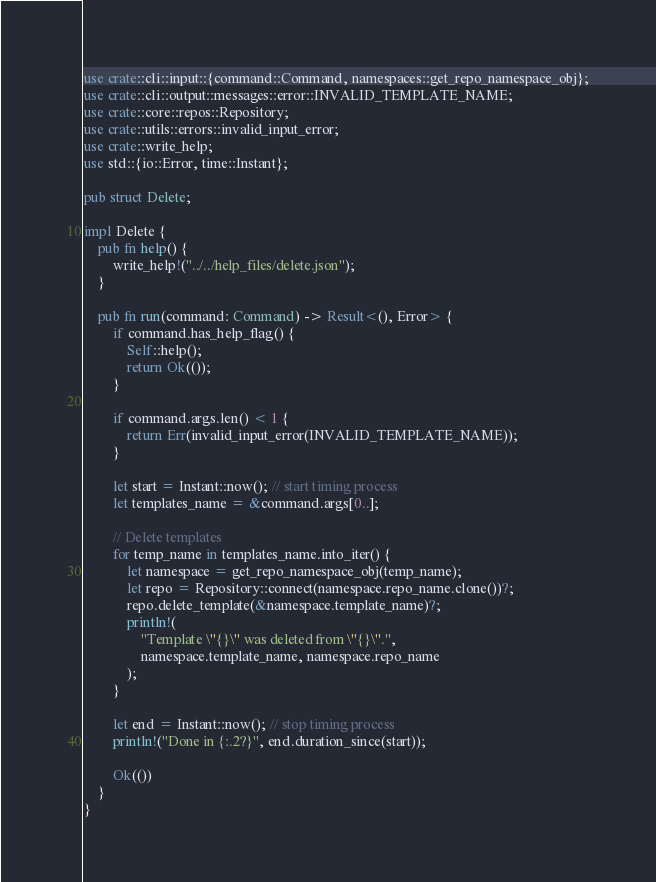Convert code to text. <code><loc_0><loc_0><loc_500><loc_500><_Rust_>use crate::cli::input::{command::Command, namespaces::get_repo_namespace_obj};
use crate::cli::output::messages::error::INVALID_TEMPLATE_NAME;
use crate::core::repos::Repository;
use crate::utils::errors::invalid_input_error;
use crate::write_help;
use std::{io::Error, time::Instant};

pub struct Delete;

impl Delete {
    pub fn help() {
        write_help!("../../help_files/delete.json");
    }

    pub fn run(command: Command) -> Result<(), Error> {
        if command.has_help_flag() {
            Self::help();
            return Ok(());
        }

        if command.args.len() < 1 {
            return Err(invalid_input_error(INVALID_TEMPLATE_NAME));
        }

        let start = Instant::now(); // start timing process
        let templates_name = &command.args[0..];

        // Delete templates
        for temp_name in templates_name.into_iter() {
            let namespace = get_repo_namespace_obj(temp_name);
            let repo = Repository::connect(namespace.repo_name.clone())?;
            repo.delete_template(&namespace.template_name)?;
            println!(
                "Template \"{}\" was deleted from \"{}\".",
                namespace.template_name, namespace.repo_name
            );
        }

        let end = Instant::now(); // stop timing process
        println!("Done in {:.2?}", end.duration_since(start));

        Ok(())
    }
}
</code> 